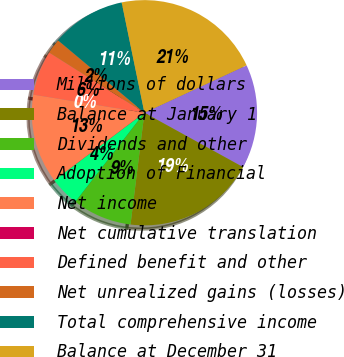<chart> <loc_0><loc_0><loc_500><loc_500><pie_chart><fcel>Millions of dollars<fcel>Balance at January 1<fcel>Dividends and other<fcel>Adoption of Financial<fcel>Net income<fcel>Net cumulative translation<fcel>Defined benefit and other<fcel>Net unrealized gains (losses)<fcel>Total comprehensive income<fcel>Balance at December 31<nl><fcel>14.93%<fcel>18.95%<fcel>8.53%<fcel>4.27%<fcel>12.8%<fcel>0.0%<fcel>6.4%<fcel>2.13%<fcel>10.66%<fcel>21.32%<nl></chart> 